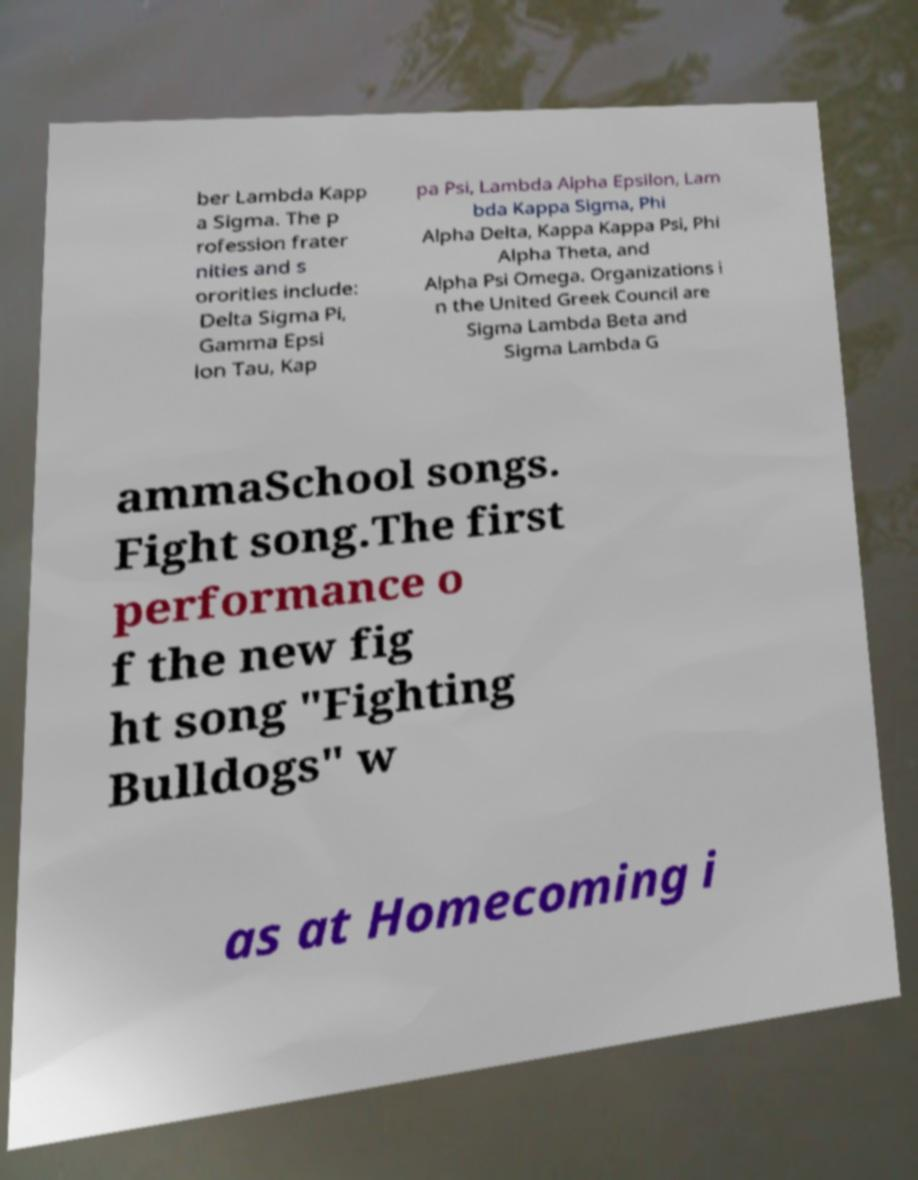What messages or text are displayed in this image? I need them in a readable, typed format. ber Lambda Kapp a Sigma. The p rofession frater nities and s ororities include: Delta Sigma Pi, Gamma Epsi lon Tau, Kap pa Psi, Lambda Alpha Epsilon, Lam bda Kappa Sigma, Phi Alpha Delta, Kappa Kappa Psi, Phi Alpha Theta, and Alpha Psi Omega. Organizations i n the United Greek Council are Sigma Lambda Beta and Sigma Lambda G ammaSchool songs. Fight song.The first performance o f the new fig ht song "Fighting Bulldogs" w as at Homecoming i 